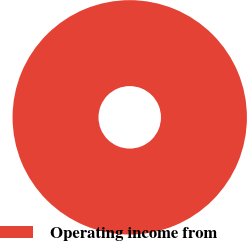Convert chart. <chart><loc_0><loc_0><loc_500><loc_500><pie_chart><fcel>Operating income from<nl><fcel>100.0%<nl></chart> 